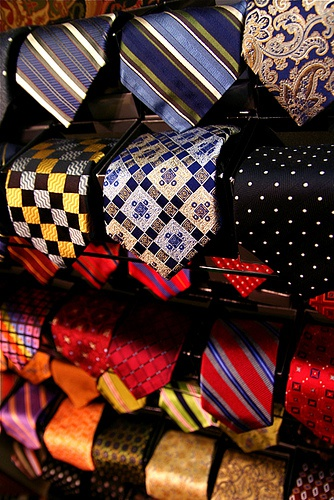Describe the objects in this image and their specific colors. I can see tie in maroon, black, and brown tones, tie in maroon, black, white, and gray tones, tie in maroon, white, black, navy, and darkgray tones, tie in maroon, navy, black, and gray tones, and tie in maroon, black, gold, and orange tones in this image. 